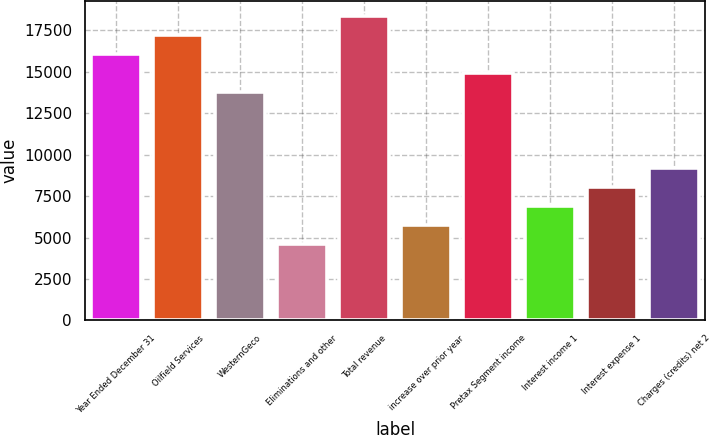<chart> <loc_0><loc_0><loc_500><loc_500><bar_chart><fcel>Year Ended December 31<fcel>Oilfield Services<fcel>WesternGeco<fcel>Eliminations and other<fcel>Total revenue<fcel>increase over prior year<fcel>Pretax Segment income<fcel>Interest income 1<fcel>Interest expense 1<fcel>Charges (credits) net 2<nl><fcel>16071.8<fcel>17219.8<fcel>13775.9<fcel>4592.22<fcel>18367.7<fcel>5740.18<fcel>14923.9<fcel>6888.14<fcel>8036.1<fcel>9184.06<nl></chart> 